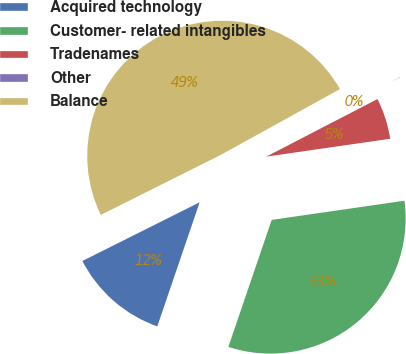Convert chart to OTSL. <chart><loc_0><loc_0><loc_500><loc_500><pie_chart><fcel>Acquired technology<fcel>Customer- related intangibles<fcel>Tradenames<fcel>Other<fcel>Balance<nl><fcel>12.38%<fcel>32.52%<fcel>5.32%<fcel>0.43%<fcel>49.35%<nl></chart> 